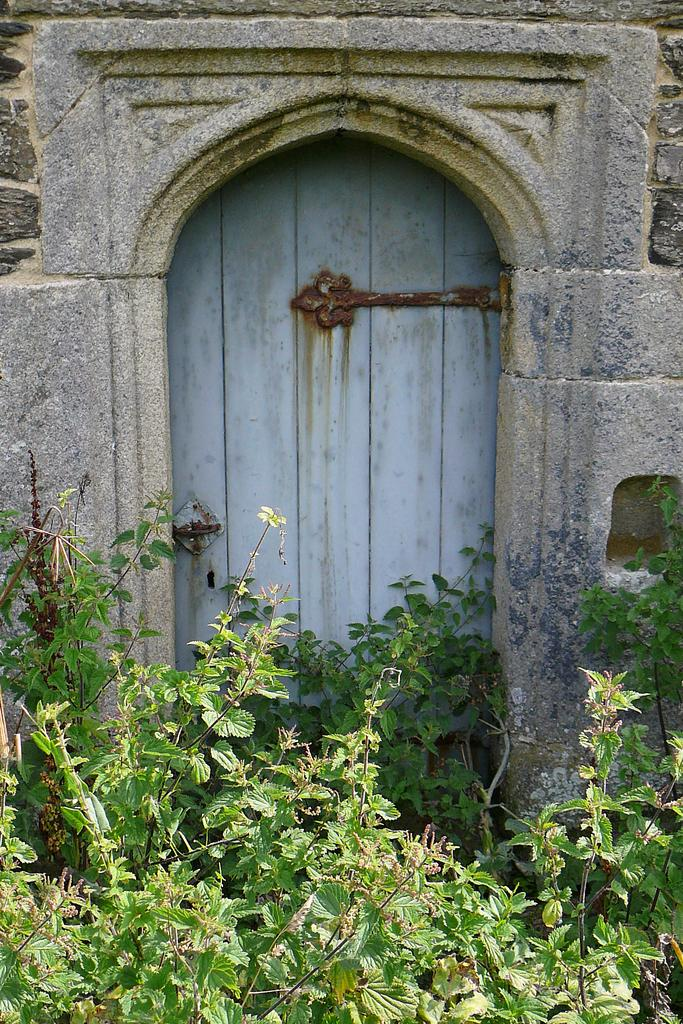What is the main object in the middle of the image? There is a door in the middle of the image. What is located next to the door? There is a wall beside the door. What type of vegetation can be seen at the bottom of the image? There are plants at the bottom of the image. How many monkeys are sitting on the fifth plant in the image? There are no monkeys or plants mentioned in the provided facts, so this question cannot be answered. 